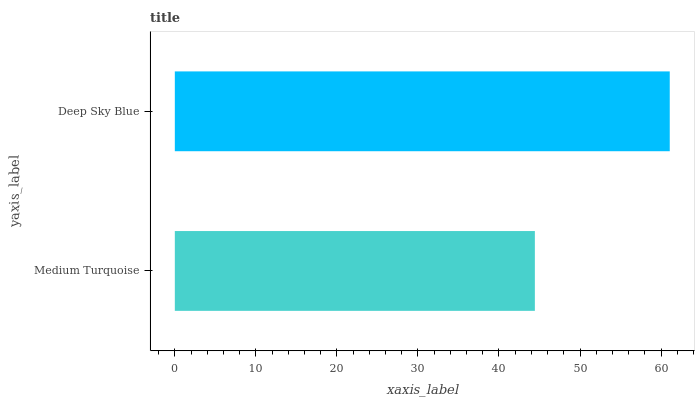Is Medium Turquoise the minimum?
Answer yes or no. Yes. Is Deep Sky Blue the maximum?
Answer yes or no. Yes. Is Deep Sky Blue the minimum?
Answer yes or no. No. Is Deep Sky Blue greater than Medium Turquoise?
Answer yes or no. Yes. Is Medium Turquoise less than Deep Sky Blue?
Answer yes or no. Yes. Is Medium Turquoise greater than Deep Sky Blue?
Answer yes or no. No. Is Deep Sky Blue less than Medium Turquoise?
Answer yes or no. No. Is Deep Sky Blue the high median?
Answer yes or no. Yes. Is Medium Turquoise the low median?
Answer yes or no. Yes. Is Medium Turquoise the high median?
Answer yes or no. No. Is Deep Sky Blue the low median?
Answer yes or no. No. 